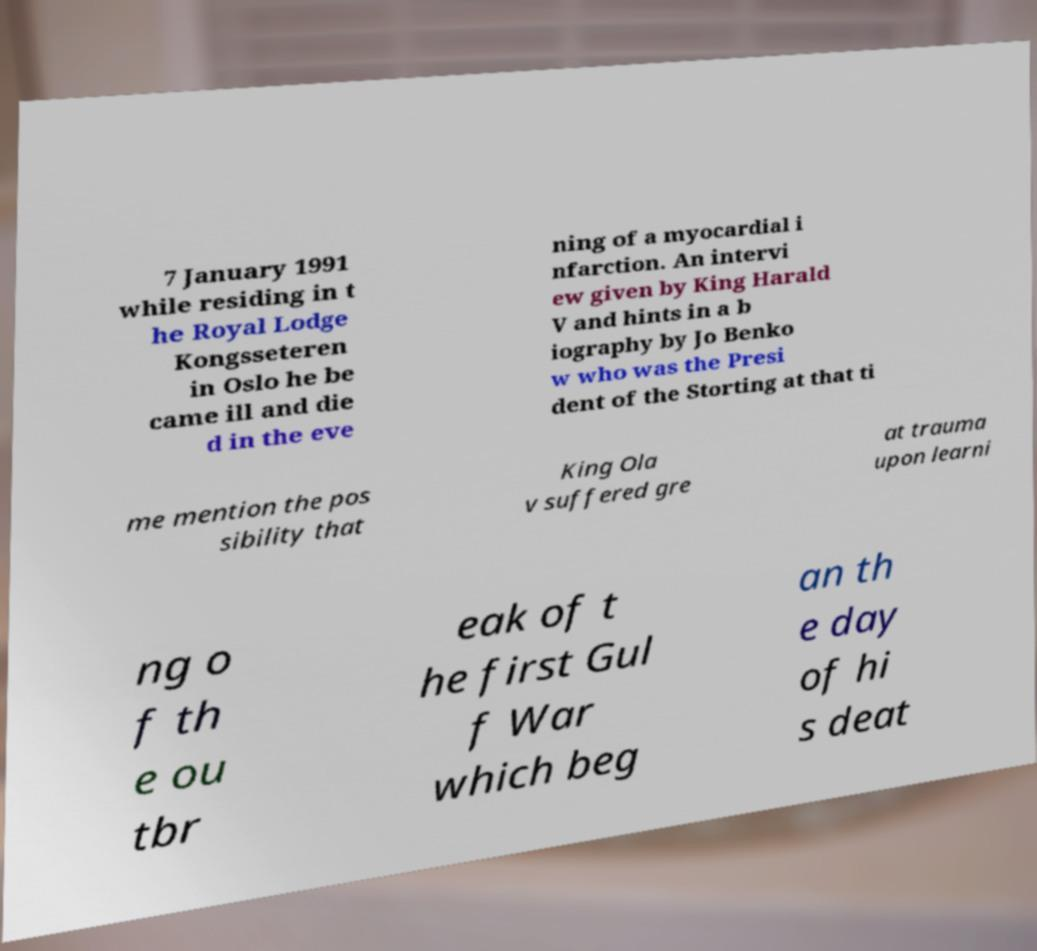Could you assist in decoding the text presented in this image and type it out clearly? 7 January 1991 while residing in t he Royal Lodge Kongsseteren in Oslo he be came ill and die d in the eve ning of a myocardial i nfarction. An intervi ew given by King Harald V and hints in a b iography by Jo Benko w who was the Presi dent of the Storting at that ti me mention the pos sibility that King Ola v suffered gre at trauma upon learni ng o f th e ou tbr eak of t he first Gul f War which beg an th e day of hi s deat 